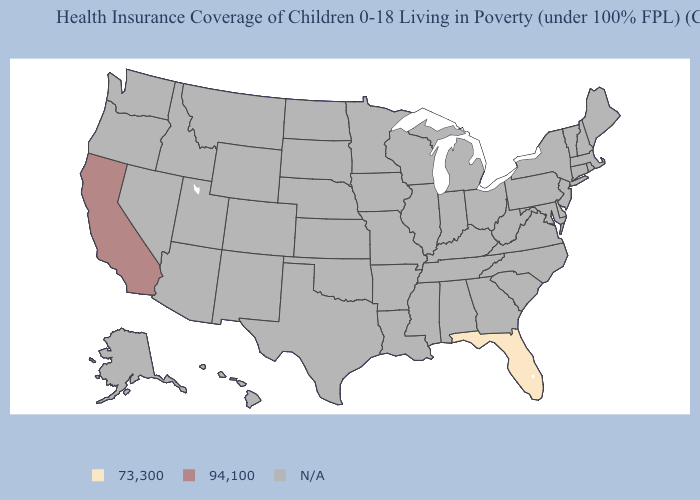How many symbols are there in the legend?
Short answer required. 3. Name the states that have a value in the range 94,100?
Be succinct. California. Name the states that have a value in the range N/A?
Write a very short answer. Alabama, Alaska, Arizona, Arkansas, Colorado, Connecticut, Delaware, Georgia, Hawaii, Idaho, Illinois, Indiana, Iowa, Kansas, Kentucky, Louisiana, Maine, Maryland, Massachusetts, Michigan, Minnesota, Mississippi, Missouri, Montana, Nebraska, Nevada, New Hampshire, New Jersey, New Mexico, New York, North Carolina, North Dakota, Ohio, Oklahoma, Oregon, Pennsylvania, Rhode Island, South Carolina, South Dakota, Tennessee, Texas, Utah, Vermont, Virginia, Washington, West Virginia, Wisconsin, Wyoming. Name the states that have a value in the range N/A?
Be succinct. Alabama, Alaska, Arizona, Arkansas, Colorado, Connecticut, Delaware, Georgia, Hawaii, Idaho, Illinois, Indiana, Iowa, Kansas, Kentucky, Louisiana, Maine, Maryland, Massachusetts, Michigan, Minnesota, Mississippi, Missouri, Montana, Nebraska, Nevada, New Hampshire, New Jersey, New Mexico, New York, North Carolina, North Dakota, Ohio, Oklahoma, Oregon, Pennsylvania, Rhode Island, South Carolina, South Dakota, Tennessee, Texas, Utah, Vermont, Virginia, Washington, West Virginia, Wisconsin, Wyoming. What is the value of Iowa?
Concise answer only. N/A. Name the states that have a value in the range 73,300?
Keep it brief. Florida. What is the value of New Mexico?
Concise answer only. N/A. Name the states that have a value in the range 73,300?
Keep it brief. Florida. Name the states that have a value in the range 94,100?
Short answer required. California. What is the value of Delaware?
Concise answer only. N/A. How many symbols are there in the legend?
Quick response, please. 3. 